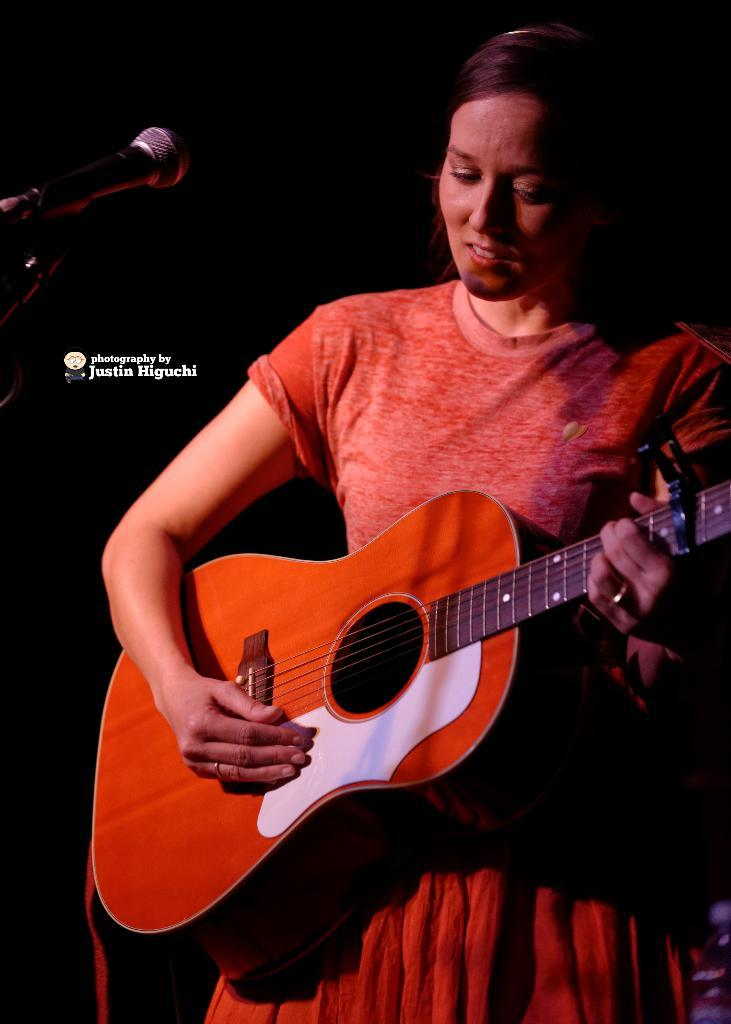Who is the main subject in the image? There is a woman in the image. What is the woman doing in the image? The woman is standing and appears to be singing. What object is the woman holding in the image? The woman is holding a guitar. Can you describe any other objects in the image? There is a microphone in the top left corner of the image. What type of guide is the woman holding in the image? There is no guide present in the image; the woman is holding a guitar. How many eggs can be seen in the image? There are no eggs present in the image. 